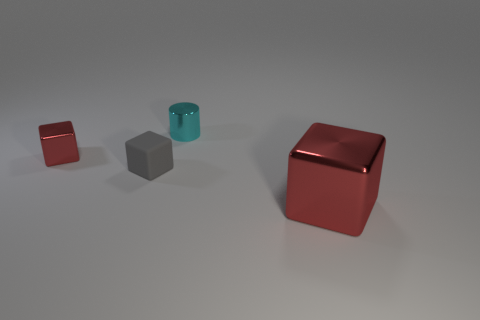Add 4 big yellow metal cubes. How many objects exist? 8 Subtract all cylinders. How many objects are left? 3 Subtract 0 blue cylinders. How many objects are left? 4 Subtract all cyan blocks. Subtract all tiny cylinders. How many objects are left? 3 Add 4 small metallic cylinders. How many small metallic cylinders are left? 5 Add 2 big gray matte cubes. How many big gray matte cubes exist? 2 